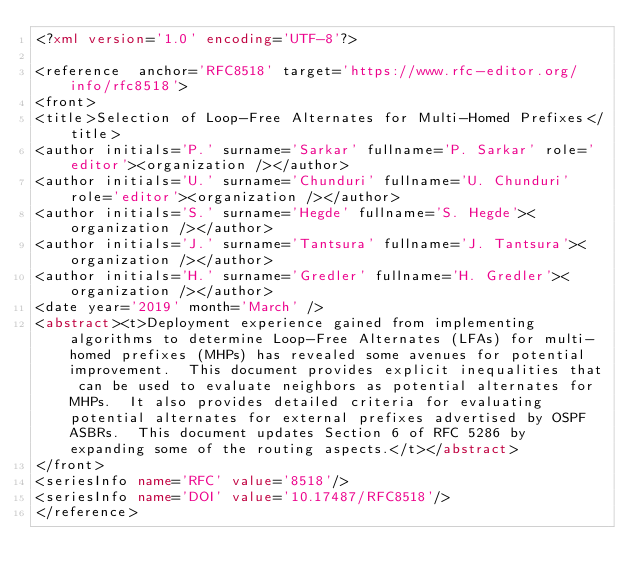<code> <loc_0><loc_0><loc_500><loc_500><_XML_><?xml version='1.0' encoding='UTF-8'?>

<reference  anchor='RFC8518' target='https://www.rfc-editor.org/info/rfc8518'>
<front>
<title>Selection of Loop-Free Alternates for Multi-Homed Prefixes</title>
<author initials='P.' surname='Sarkar' fullname='P. Sarkar' role='editor'><organization /></author>
<author initials='U.' surname='Chunduri' fullname='U. Chunduri' role='editor'><organization /></author>
<author initials='S.' surname='Hegde' fullname='S. Hegde'><organization /></author>
<author initials='J.' surname='Tantsura' fullname='J. Tantsura'><organization /></author>
<author initials='H.' surname='Gredler' fullname='H. Gredler'><organization /></author>
<date year='2019' month='March' />
<abstract><t>Deployment experience gained from implementing algorithms to determine Loop-Free Alternates (LFAs) for multi-homed prefixes (MHPs) has revealed some avenues for potential improvement.  This document provides explicit inequalities that can be used to evaluate neighbors as potential alternates for MHPs.  It also provides detailed criteria for evaluating potential alternates for external prefixes advertised by OSPF ASBRs.  This document updates Section 6 of RFC 5286 by expanding some of the routing aspects.</t></abstract>
</front>
<seriesInfo name='RFC' value='8518'/>
<seriesInfo name='DOI' value='10.17487/RFC8518'/>
</reference>
</code> 